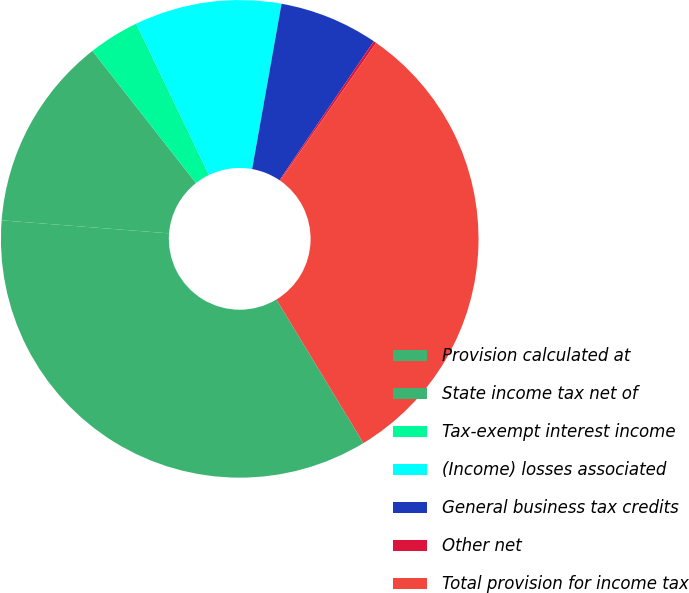Convert chart. <chart><loc_0><loc_0><loc_500><loc_500><pie_chart><fcel>Provision calculated at<fcel>State income tax net of<fcel>Tax-exempt interest income<fcel>(Income) losses associated<fcel>General business tax credits<fcel>Other net<fcel>Total provision for income tax<nl><fcel>34.91%<fcel>13.19%<fcel>3.44%<fcel>9.94%<fcel>6.69%<fcel>0.19%<fcel>31.66%<nl></chart> 